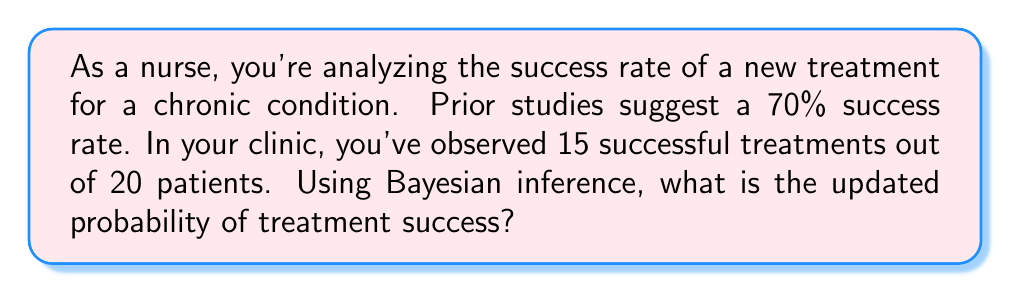Give your solution to this math problem. Let's approach this step-by-step using Bayes' theorem:

1) Let $A$ be the event of treatment success.

2) Prior probability (from previous studies): $P(A) = 0.70$

3) Likelihood of observing 15 successes out of 20 trials, given the true probability is 0.70:
   $P(B|A) = \binom{20}{15} (0.70)^{15} (0.30)^5$

4) We also need $P(B|\text{not }A)$. Let's assume if the treatment isn't generally successful, it would have a 30% success rate:
   $P(B|\text{not }A) = \binom{20}{15} (0.30)^{15} (0.70)^5$

5) Bayes' theorem:
   $$P(A|B) = \frac{P(B|A)P(A)}{P(B|A)P(A) + P(B|\text{not }A)P(\text{not }A)}$$

6) Substituting the values:
   $$P(A|B) = \frac{\binom{20}{15} (0.70)^{15} (0.30)^5 \cdot 0.70}{\binom{20}{15} (0.70)^{15} (0.30)^5 \cdot 0.70 + \binom{20}{15} (0.30)^{15} (0.70)^5 \cdot 0.30}$$

7) Simplifying:
   $$P(A|B) = \frac{0.70 \cdot 0.70^{15} \cdot 0.30^5}{0.70 \cdot 0.70^{15} \cdot 0.30^5 + 0.30 \cdot 0.30^{15} \cdot 0.70^5}$$

8) Calculating:
   $$P(A|B) \approx 0.9052$$

Therefore, the updated probability of treatment success is approximately 0.9052 or 90.52%.
Answer: 0.9052 